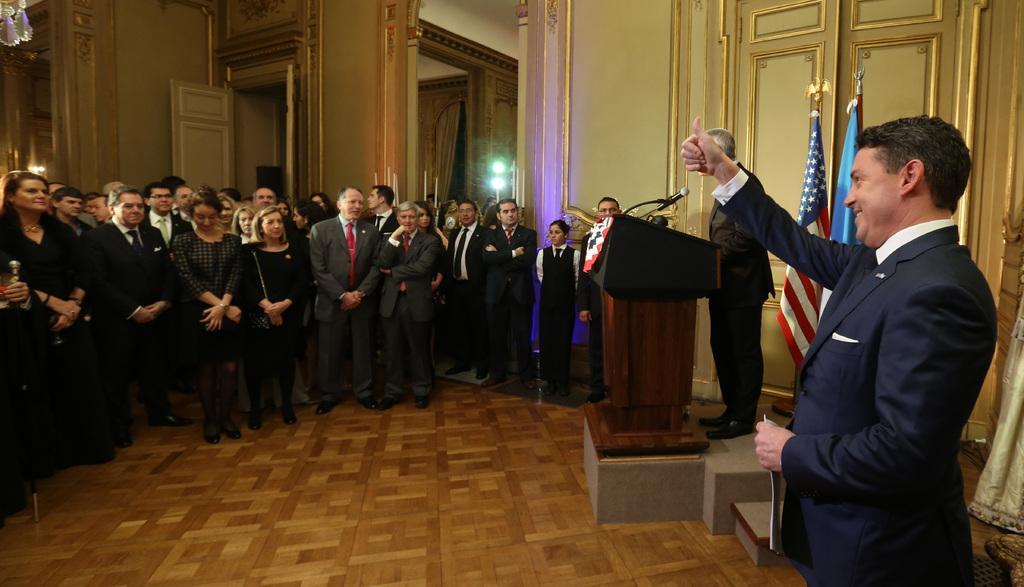In one or two sentences, can you explain what this image depicts? This image is taken indoors. At the bottom of the image there is a floor. In the background there are a few walls with doors and there is a curtain. There are two lamps. On the right side of the image there is a wall with carvings. A man is standing on the floor and there are two flags. Another man is standing on the dais and there is a podium with a mic on it. In the middle of the image many people are standing on the floor. 